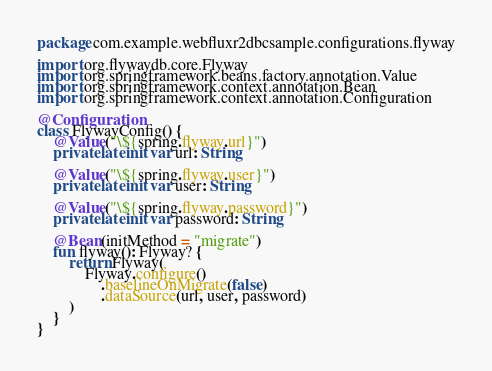Convert code to text. <code><loc_0><loc_0><loc_500><loc_500><_Kotlin_>package com.example.webfluxr2dbcsample.configurations.flyway

import org.flywaydb.core.Flyway
import org.springframework.beans.factory.annotation.Value
import org.springframework.context.annotation.Bean
import org.springframework.context.annotation.Configuration

@Configuration
class FlywayConfig() {
    @Value("\${spring.flyway.url}")
    private lateinit var url: String

    @Value("\${spring.flyway.user}")
    private lateinit var user: String

    @Value("\${spring.flyway.password}")
    private lateinit var password: String

    @Bean(initMethod = "migrate")
    fun flyway(): Flyway? {
        return Flyway(
            Flyway.configure()
                .baselineOnMigrate(false)
                .dataSource(url, user, password)
        )
    }
}
</code> 